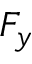Convert formula to latex. <formula><loc_0><loc_0><loc_500><loc_500>F _ { y }</formula> 